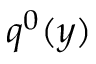<formula> <loc_0><loc_0><loc_500><loc_500>q ^ { 0 } ( y )</formula> 